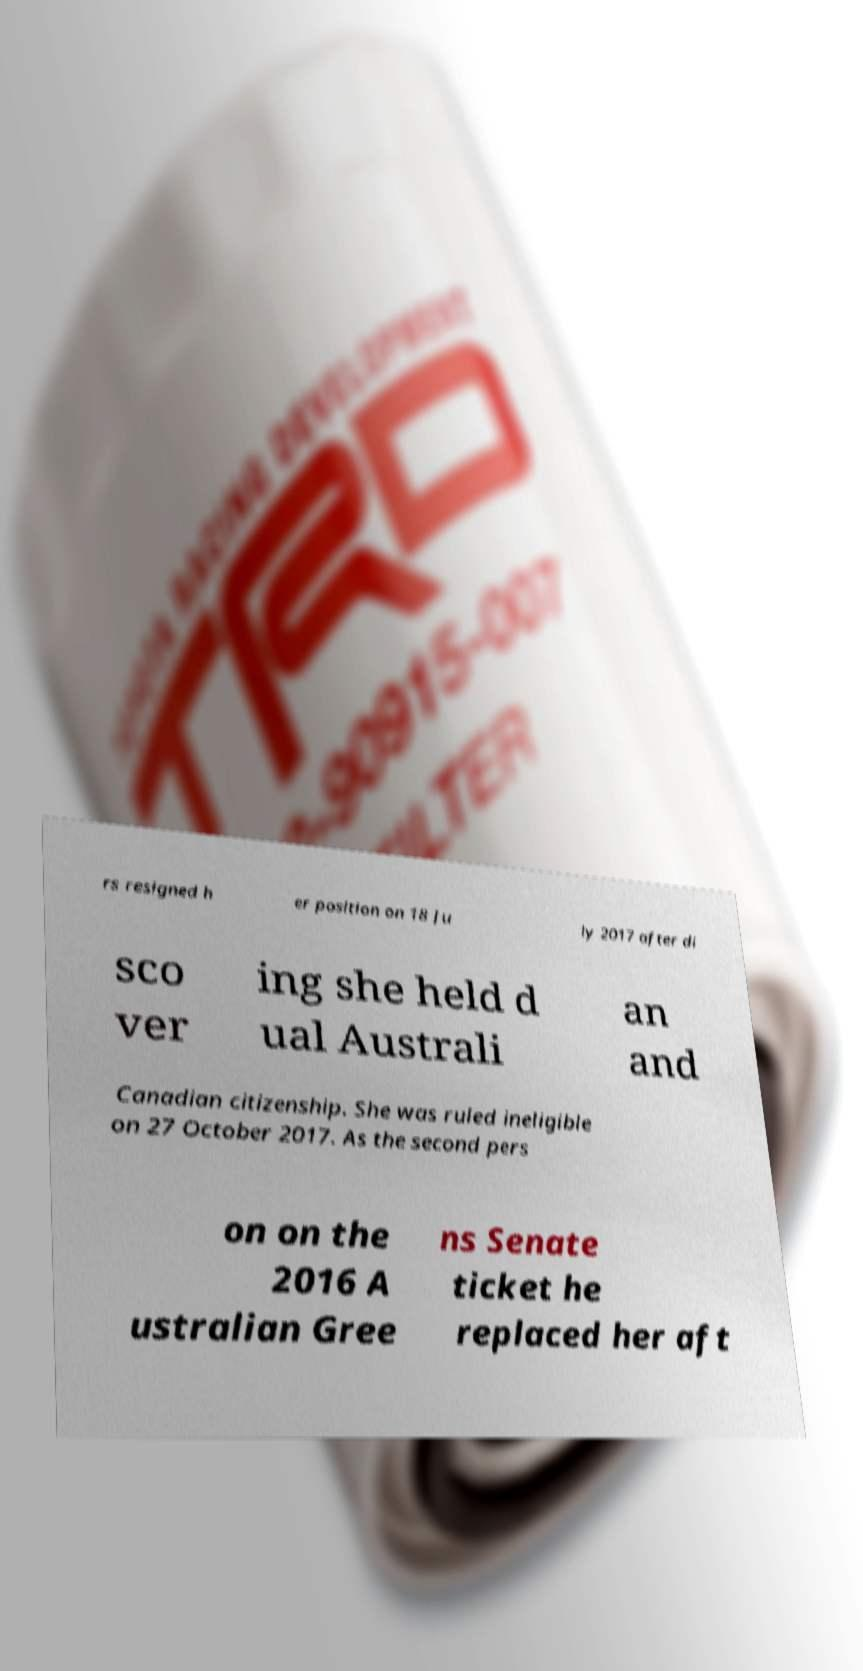Could you assist in decoding the text presented in this image and type it out clearly? rs resigned h er position on 18 Ju ly 2017 after di sco ver ing she held d ual Australi an and Canadian citizenship. She was ruled ineligible on 27 October 2017. As the second pers on on the 2016 A ustralian Gree ns Senate ticket he replaced her aft 